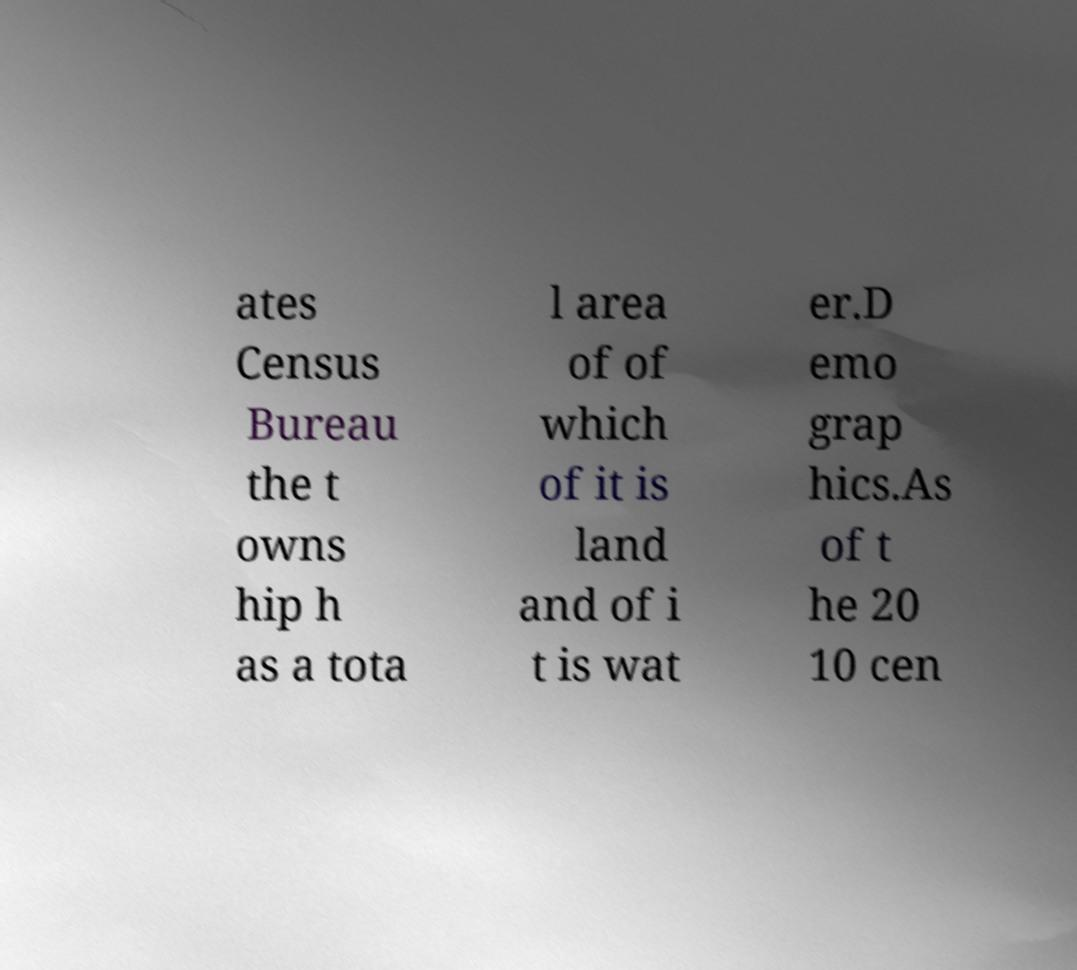I need the written content from this picture converted into text. Can you do that? ates Census Bureau the t owns hip h as a tota l area of of which of it is land and of i t is wat er.D emo grap hics.As of t he 20 10 cen 